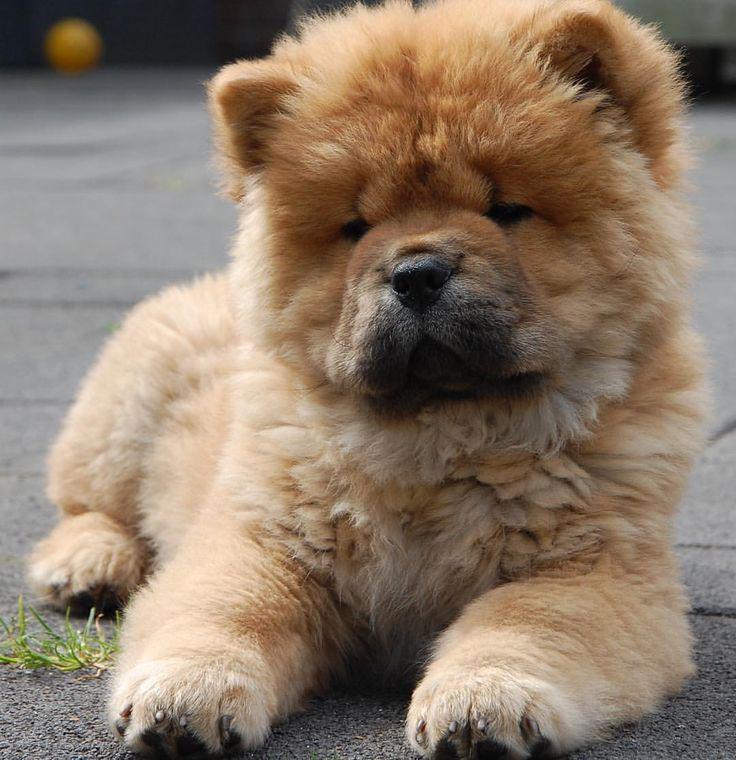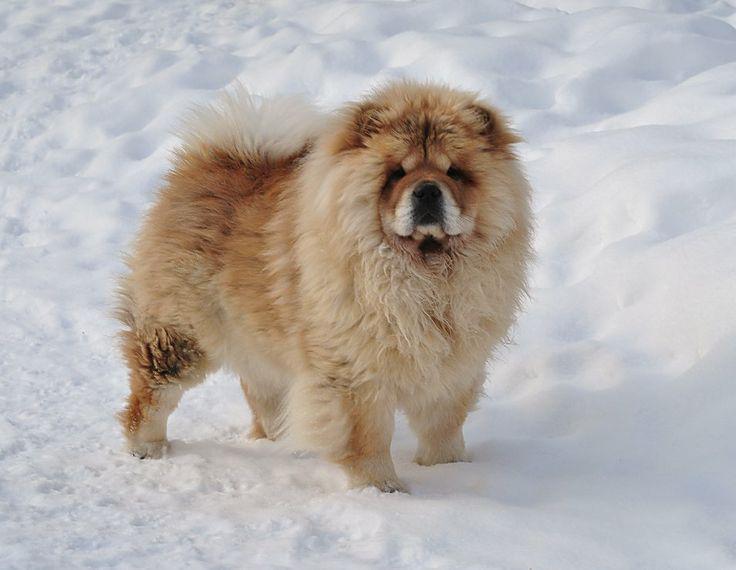The first image is the image on the left, the second image is the image on the right. Assess this claim about the two images: "The dog in the image on the right has its mouth open". Correct or not? Answer yes or no. No. 